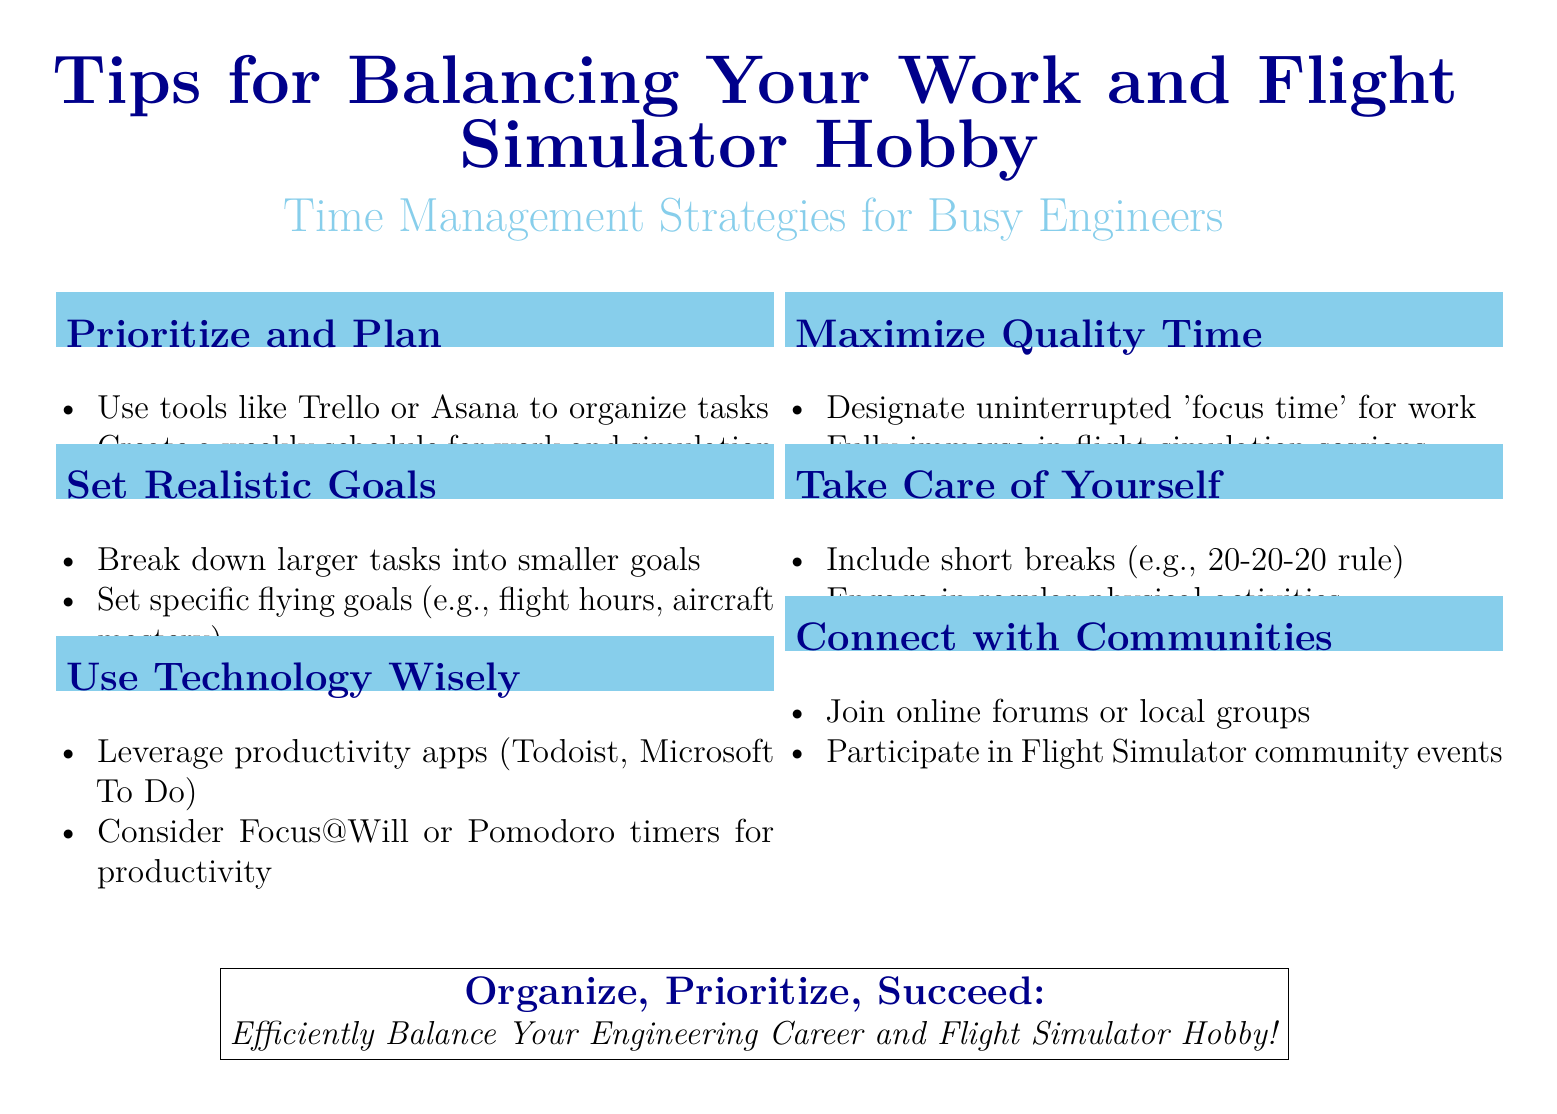what are the tools suggested for organizing tasks? The document lists Trello and Asana as tools for organizing tasks.
Answer: Trello, Asana what is the main benefit of designating 'focus time' for work? The document emphasizes that designating uninterrupted 'focus time' allows for maximum productivity and immersion in activities.
Answer: Maximum productivity how should larger tasks be managed according to the flyer? The flyer advises breaking down larger tasks into smaller manageable goals for better effectiveness.
Answer: Break down what rule is suggested for taking breaks? The flyer mentions the 20-20-20 rule as a guideline for taking breaks to protect eye health.
Answer: 20-20-20 what type of communities should flyers connect with? The document encourages joining online forums or local groups related to flight simulation for connection and support.
Answer: Online forums, local groups which productivity apps are recommended for busy engineers? The document recommends using Todoist and Microsoft To Do as productivity apps to manage tasks efficiently.
Answer: Todoist, Microsoft To Do what is the overall theme of the flyer? The primary focus of the flyer is to provide strategies for balancing work and flight simulator hobbies effectively.
Answer: Balance work and hobby how can physical activity impact productivity? The flyer suggests that engaging in regular physical activities contributes positively to overall well-being and productivity.
Answer: Positively what type of goals should be set for flying according to the document? The document suggests setting specific flying goals, such as flight hours and aircraft mastery.
Answer: Flight hours, aircraft mastery 